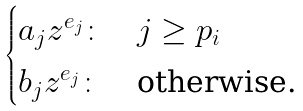Convert formula to latex. <formula><loc_0><loc_0><loc_500><loc_500>\begin{cases} a _ { j } z ^ { e _ { j } } \colon & j \geq p _ { i } \\ b _ { j } z ^ { e _ { j } } \colon & \text {otherwise.} \end{cases}</formula> 